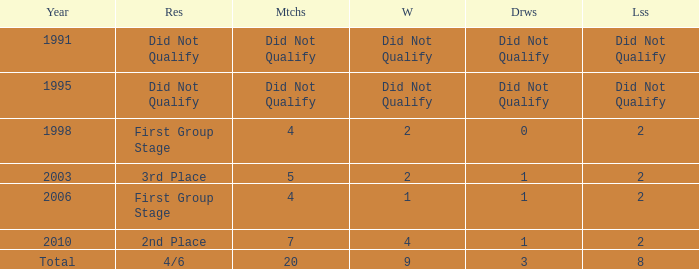What was the result for the team with 3 draws? 4/6. 